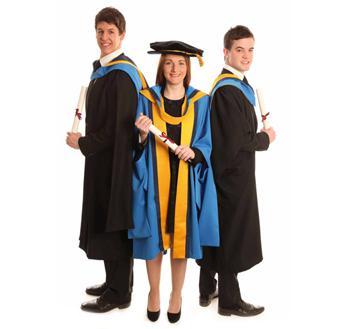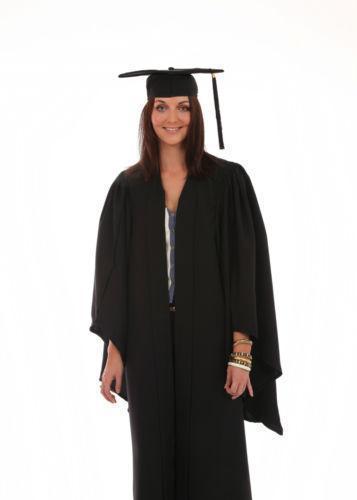The first image is the image on the left, the second image is the image on the right. Analyze the images presented: Is the assertion "At least one gown in the pair has a yellow part to the sash." valid? Answer yes or no. Yes. 